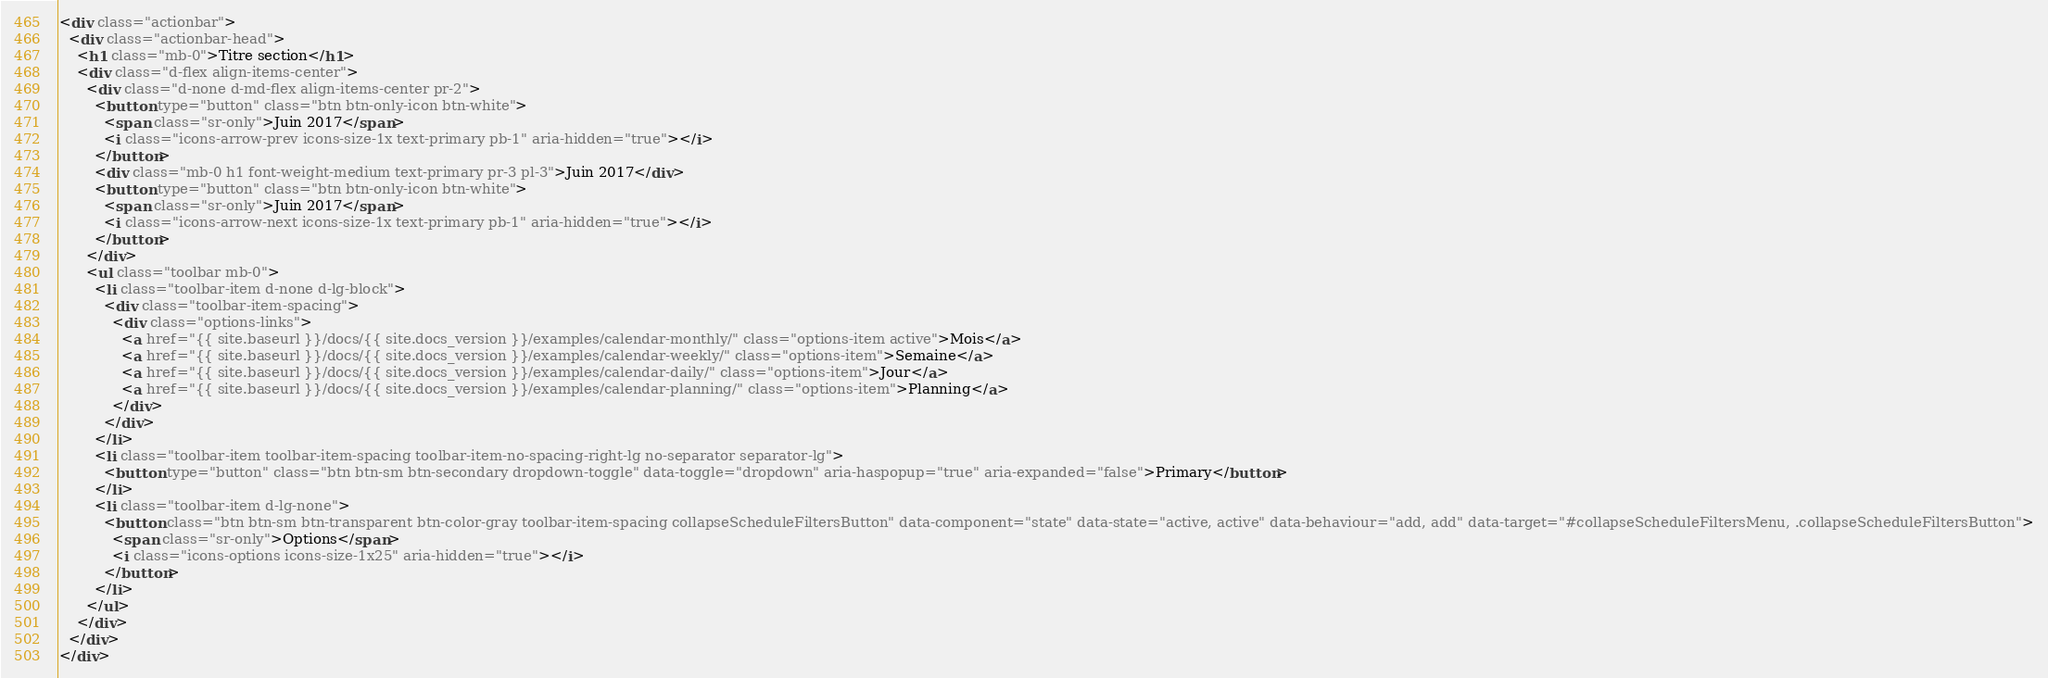<code> <loc_0><loc_0><loc_500><loc_500><_HTML_><div class="actionbar">
  <div class="actionbar-head">
    <h1 class="mb-0">Titre section</h1>
    <div class="d-flex align-items-center">
      <div class="d-none d-md-flex align-items-center pr-2">
        <button type="button" class="btn btn-only-icon btn-white">
          <span class="sr-only">Juin 2017</span>
          <i class="icons-arrow-prev icons-size-1x text-primary pb-1" aria-hidden="true"></i>
        </button>
        <div class="mb-0 h1 font-weight-medium text-primary pr-3 pl-3">Juin 2017</div>
        <button type="button" class="btn btn-only-icon btn-white">
          <span class="sr-only">Juin 2017</span>
          <i class="icons-arrow-next icons-size-1x text-primary pb-1" aria-hidden="true"></i>
        </button>
      </div>
      <ul class="toolbar mb-0">
        <li class="toolbar-item d-none d-lg-block">
          <div class="toolbar-item-spacing">
            <div class="options-links">
              <a href="{{ site.baseurl }}/docs/{{ site.docs_version }}/examples/calendar-monthly/" class="options-item active">Mois</a>
              <a href="{{ site.baseurl }}/docs/{{ site.docs_version }}/examples/calendar-weekly/" class="options-item">Semaine</a>
              <a href="{{ site.baseurl }}/docs/{{ site.docs_version }}/examples/calendar-daily/" class="options-item">Jour</a>
              <a href="{{ site.baseurl }}/docs/{{ site.docs_version }}/examples/calendar-planning/" class="options-item">Planning</a>
            </div>
          </div>
        </li>
        <li class="toolbar-item toolbar-item-spacing toolbar-item-no-spacing-right-lg no-separator separator-lg">
          <button type="button" class="btn btn-sm btn-secondary dropdown-toggle" data-toggle="dropdown" aria-haspopup="true" aria-expanded="false">Primary</button>
        </li>
        <li class="toolbar-item d-lg-none">
          <button class="btn btn-sm btn-transparent btn-color-gray toolbar-item-spacing collapseScheduleFiltersButton" data-component="state" data-state="active, active" data-behaviour="add, add" data-target="#collapseScheduleFiltersMenu, .collapseScheduleFiltersButton">
            <span class="sr-only">Options</span>
            <i class="icons-options icons-size-1x25" aria-hidden="true"></i>
          </button>
        </li>
      </ul>
    </div>
  </div>
</div></code> 